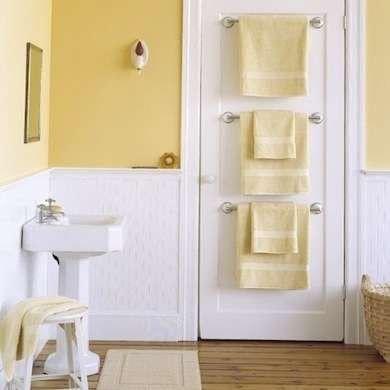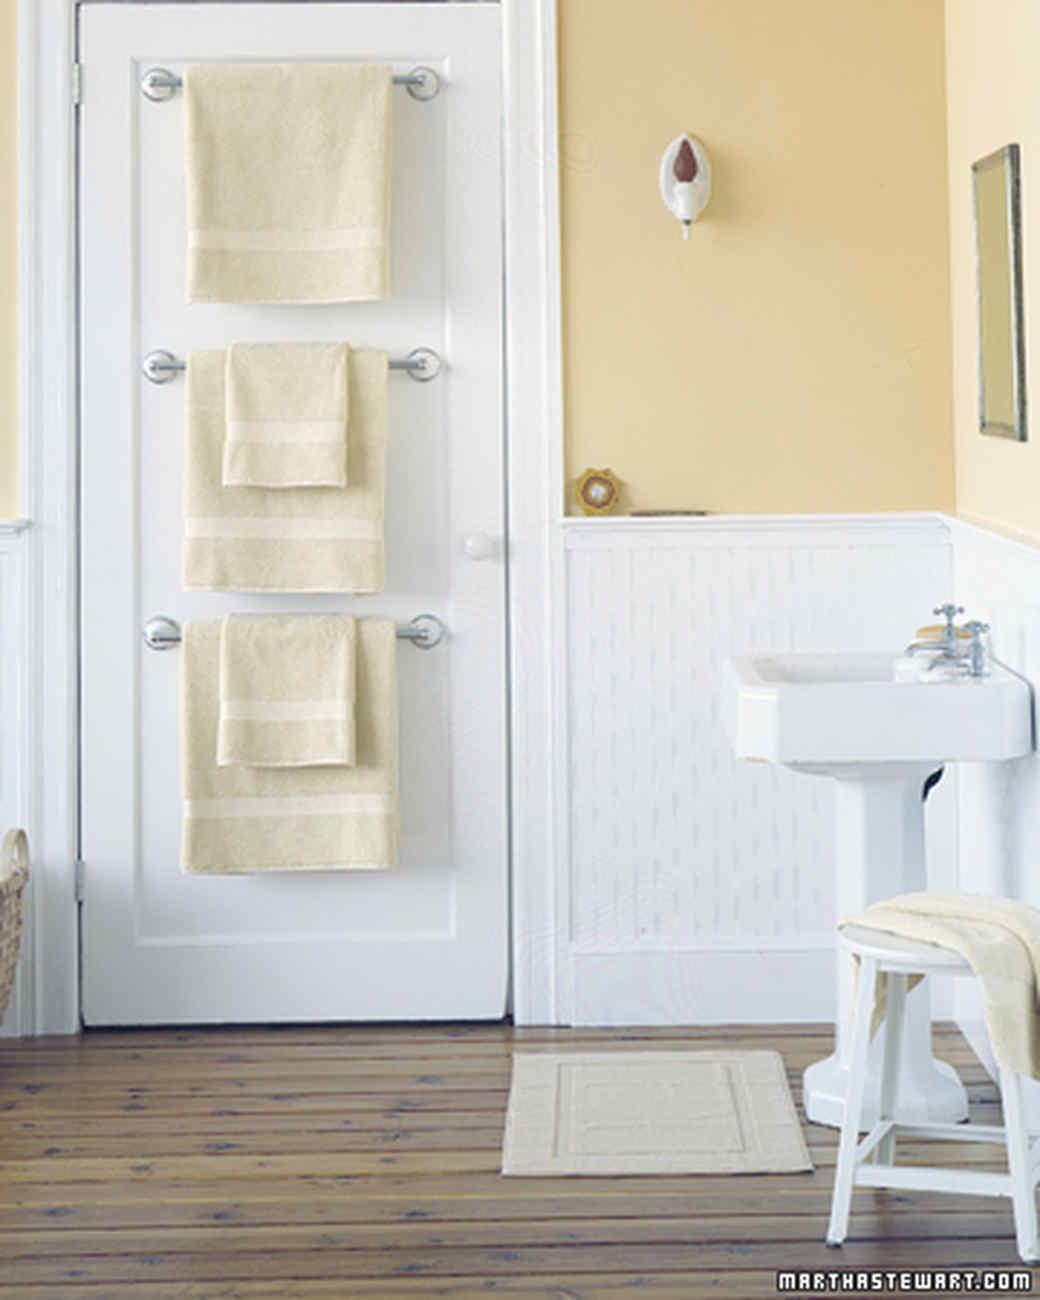The first image is the image on the left, the second image is the image on the right. Evaluate the accuracy of this statement regarding the images: "white towels are on a rack on the floor". Is it true? Answer yes or no. No. 